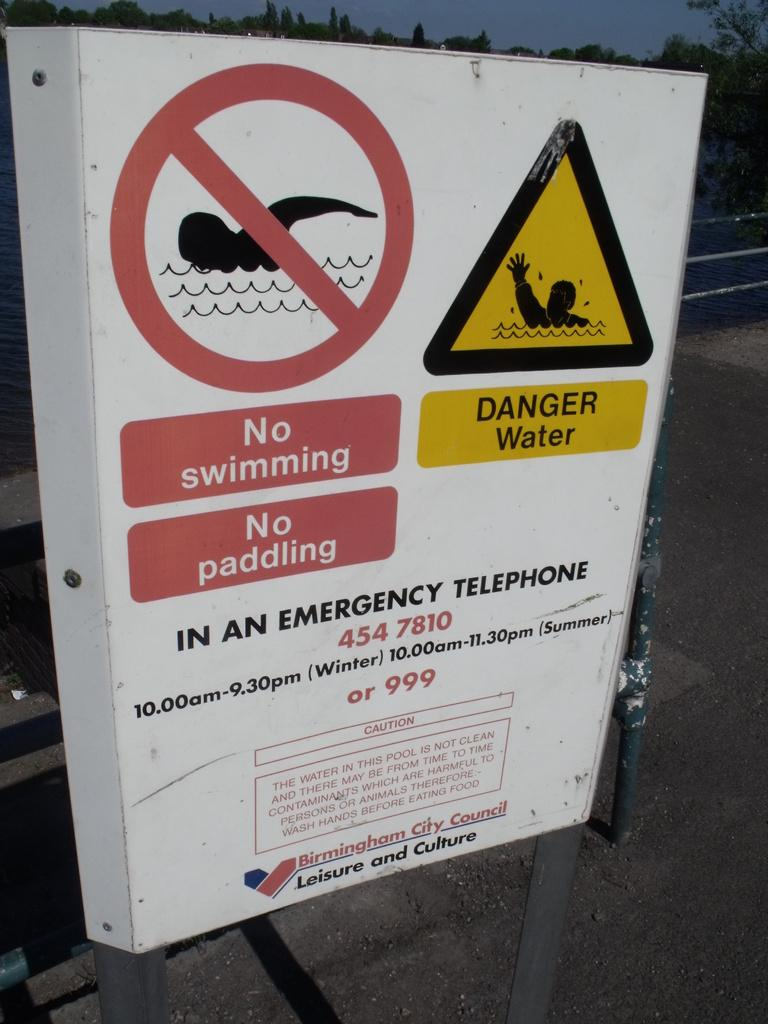Provide a one-sentence caption for the provided image. A white warning sign put up by Birmingham City Council to warn against swimming and paddling in water. 